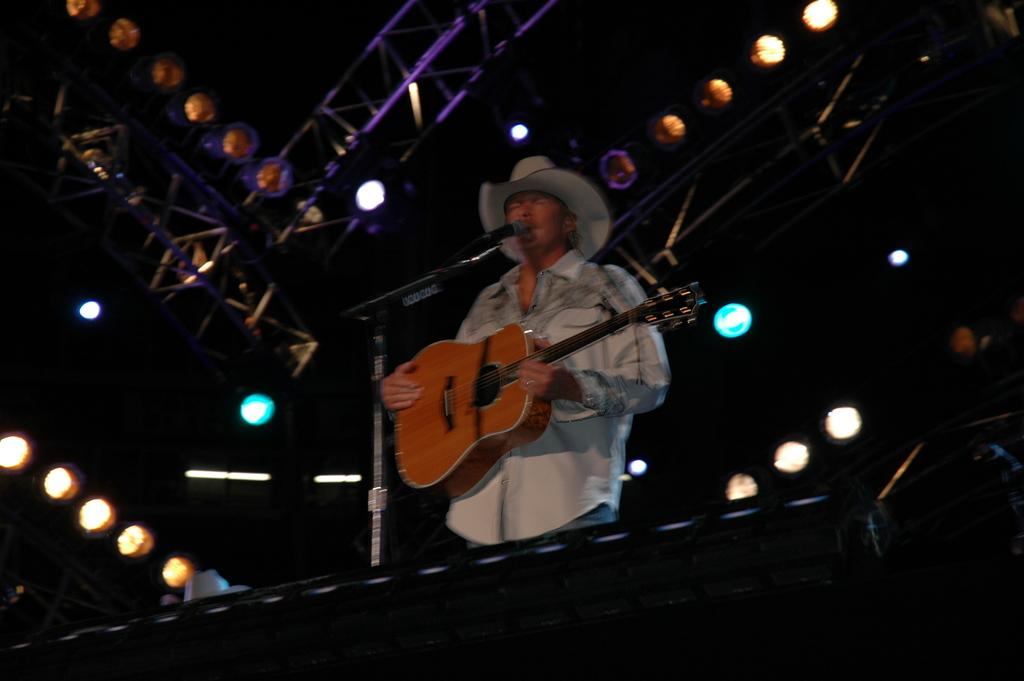What objects can be seen in the image related to lighting? There are lights in the image. What is the man in the image holding? The man is holding a guitar in the image. What device is in front of the man in the image? There is a microphone (mic) in front of the man in the image. Where is the throne located in the image? There is no throne present in the image. What color is the scarf that the man is wearing in the image? The man is not wearing a scarf in the image. 